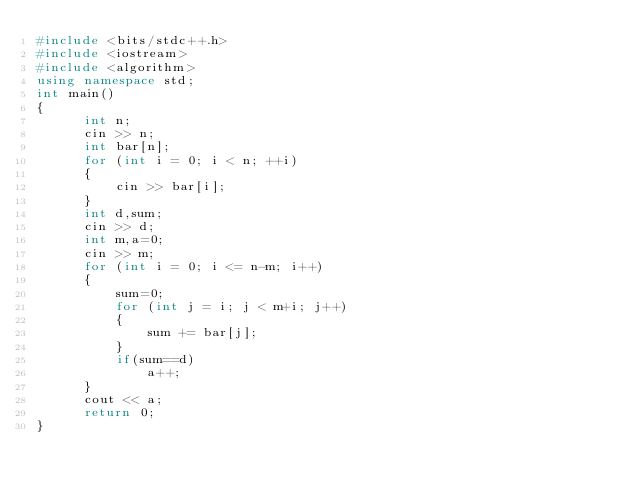<code> <loc_0><loc_0><loc_500><loc_500><_C++_>#include <bits/stdc++.h>
#include <iostream>
#include <algorithm>
using namespace std;
int main()
{
      int n;
      cin >> n;
      int bar[n];
      for (int i = 0; i < n; ++i)
      {
          cin >> bar[i];
      }
      int d,sum;
      cin >> d;
      int m,a=0;
      cin >> m;
      for (int i = 0; i <= n-m; i++)
      {
          sum=0;
          for (int j = i; j < m+i; j++)
          {
              sum += bar[j];
          }
          if(sum==d)
              a++;
      }
      cout << a;
      return 0;
}
</code> 